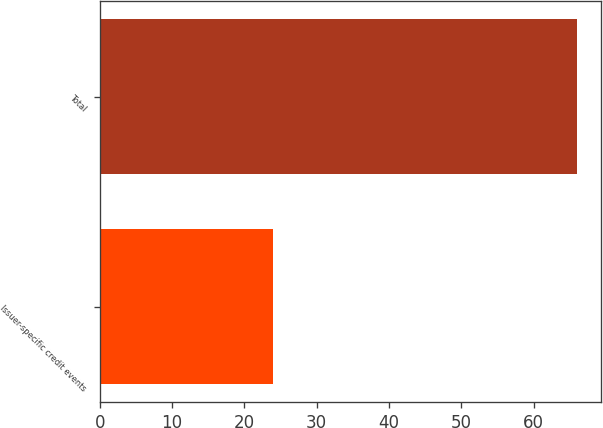Convert chart to OTSL. <chart><loc_0><loc_0><loc_500><loc_500><bar_chart><fcel>Issuer-specific credit events<fcel>Total<nl><fcel>24<fcel>66<nl></chart> 